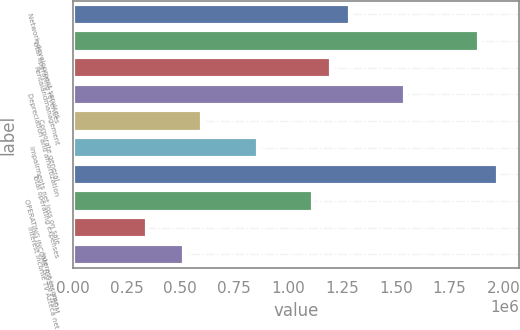Convert chart. <chart><loc_0><loc_0><loc_500><loc_500><bar_chart><fcel>Network development services<fcel>Total operating revenues<fcel>Rentalandmanagement<fcel>Depreciation and amortization<fcel>Corporate general<fcel>Impairments net loss on sale<fcel>Total operating expenses<fcel>OPERATING INCOME (LOSS) FROM<fcel>Interest income TV Azteca net<fcel>Interest income<nl><fcel>1.28732e+06<fcel>1.88807e+06<fcel>1.2015e+06<fcel>1.54478e+06<fcel>600750<fcel>858214<fcel>1.97389e+06<fcel>1.11568e+06<fcel>343286<fcel>514929<nl></chart> 